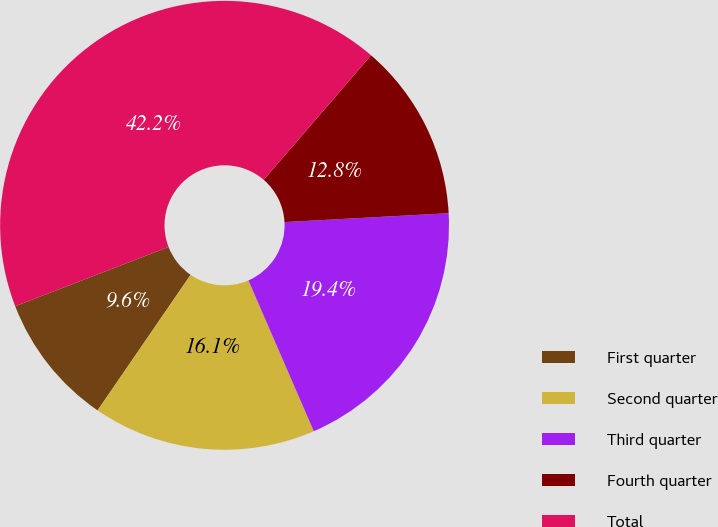Convert chart to OTSL. <chart><loc_0><loc_0><loc_500><loc_500><pie_chart><fcel>First quarter<fcel>Second quarter<fcel>Third quarter<fcel>Fourth quarter<fcel>Total<nl><fcel>9.56%<fcel>16.08%<fcel>19.35%<fcel>12.82%<fcel>42.19%<nl></chart> 